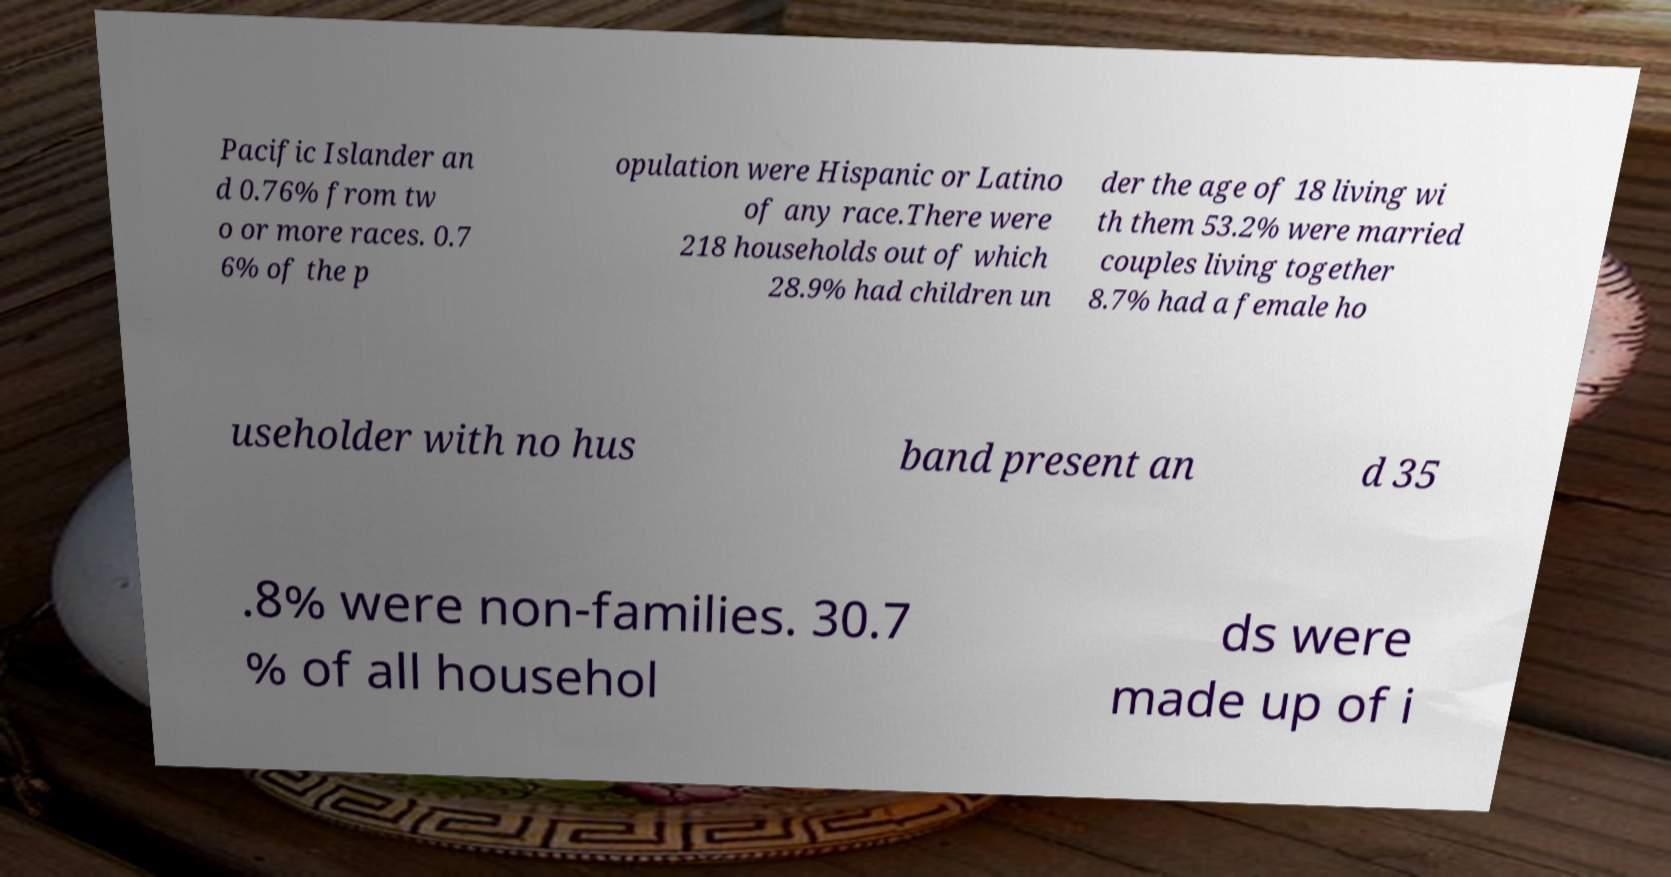Could you assist in decoding the text presented in this image and type it out clearly? Pacific Islander an d 0.76% from tw o or more races. 0.7 6% of the p opulation were Hispanic or Latino of any race.There were 218 households out of which 28.9% had children un der the age of 18 living wi th them 53.2% were married couples living together 8.7% had a female ho useholder with no hus band present an d 35 .8% were non-families. 30.7 % of all househol ds were made up of i 